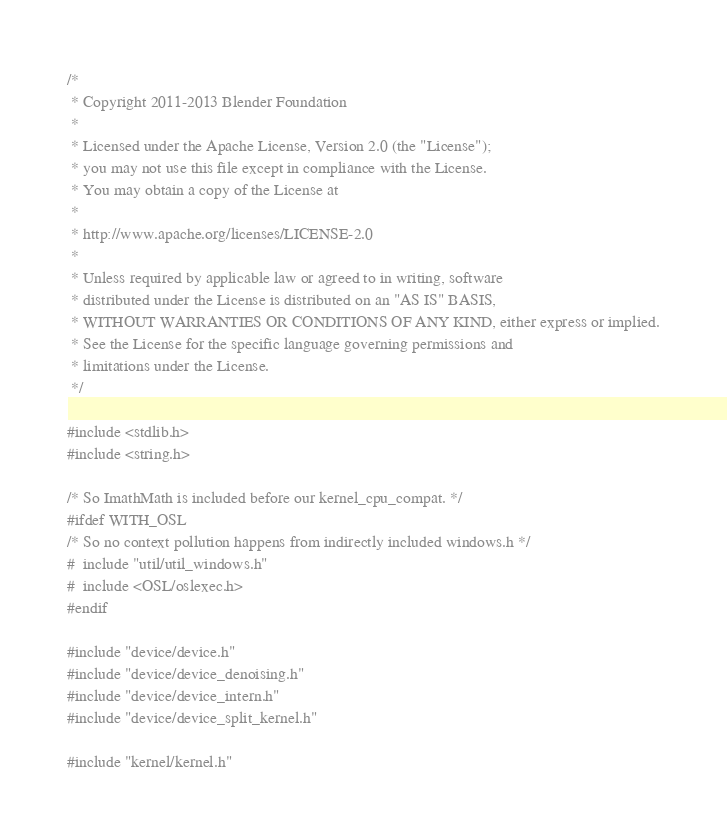<code> <loc_0><loc_0><loc_500><loc_500><_C++_>/*
 * Copyright 2011-2013 Blender Foundation
 *
 * Licensed under the Apache License, Version 2.0 (the "License");
 * you may not use this file except in compliance with the License.
 * You may obtain a copy of the License at
 *
 * http://www.apache.org/licenses/LICENSE-2.0
 *
 * Unless required by applicable law or agreed to in writing, software
 * distributed under the License is distributed on an "AS IS" BASIS,
 * WITHOUT WARRANTIES OR CONDITIONS OF ANY KIND, either express or implied.
 * See the License for the specific language governing permissions and
 * limitations under the License.
 */

#include <stdlib.h>
#include <string.h>

/* So ImathMath is included before our kernel_cpu_compat. */
#ifdef WITH_OSL
/* So no context pollution happens from indirectly included windows.h */
#  include "util/util_windows.h"
#  include <OSL/oslexec.h>
#endif

#include "device/device.h"
#include "device/device_denoising.h"
#include "device/device_intern.h"
#include "device/device_split_kernel.h"

#include "kernel/kernel.h"</code> 